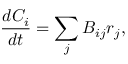Convert formula to latex. <formula><loc_0><loc_0><loc_500><loc_500>\frac { d C _ { i } } { d t } = \sum _ { j } B _ { i j } r _ { j } ,</formula> 